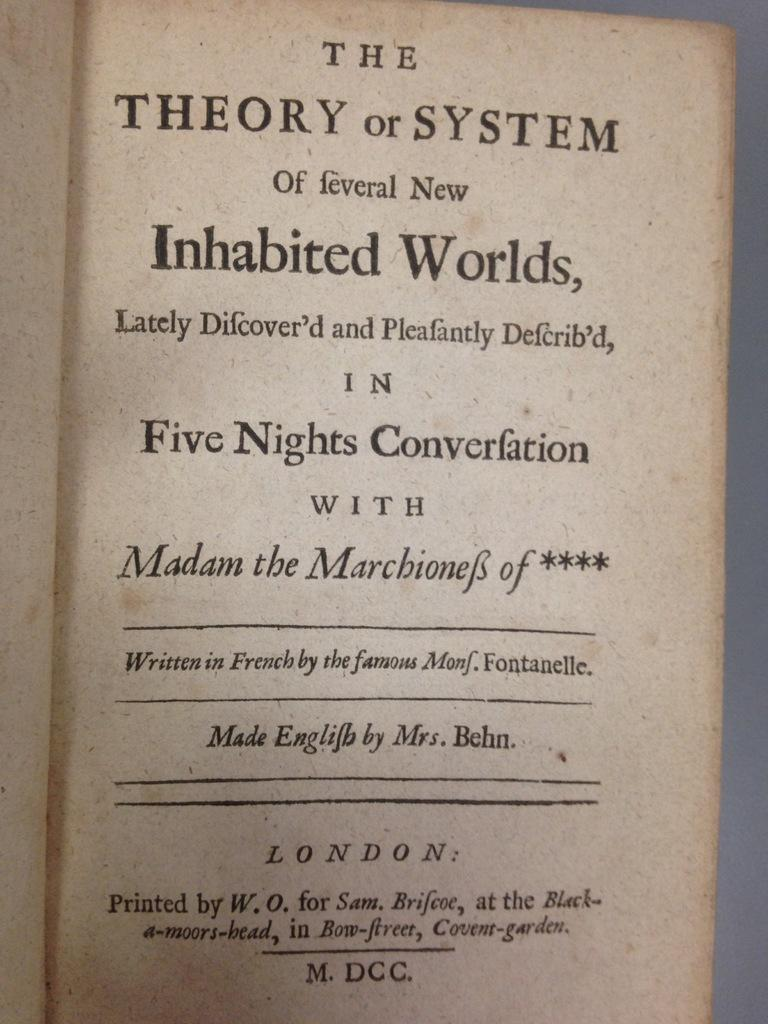<image>
Provide a brief description of the given image. A title page of the book called The Theory or System of Feveral New Inhabited Worlds. 